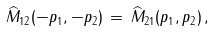<formula> <loc_0><loc_0><loc_500><loc_500>\widehat { M } _ { 1 2 } ( - p _ { 1 } , - p _ { 2 } ) \, = \, \widehat { M } _ { 2 1 } ( p _ { 1 } , p _ { 2 } ) \, ,</formula> 